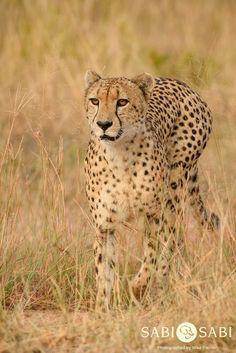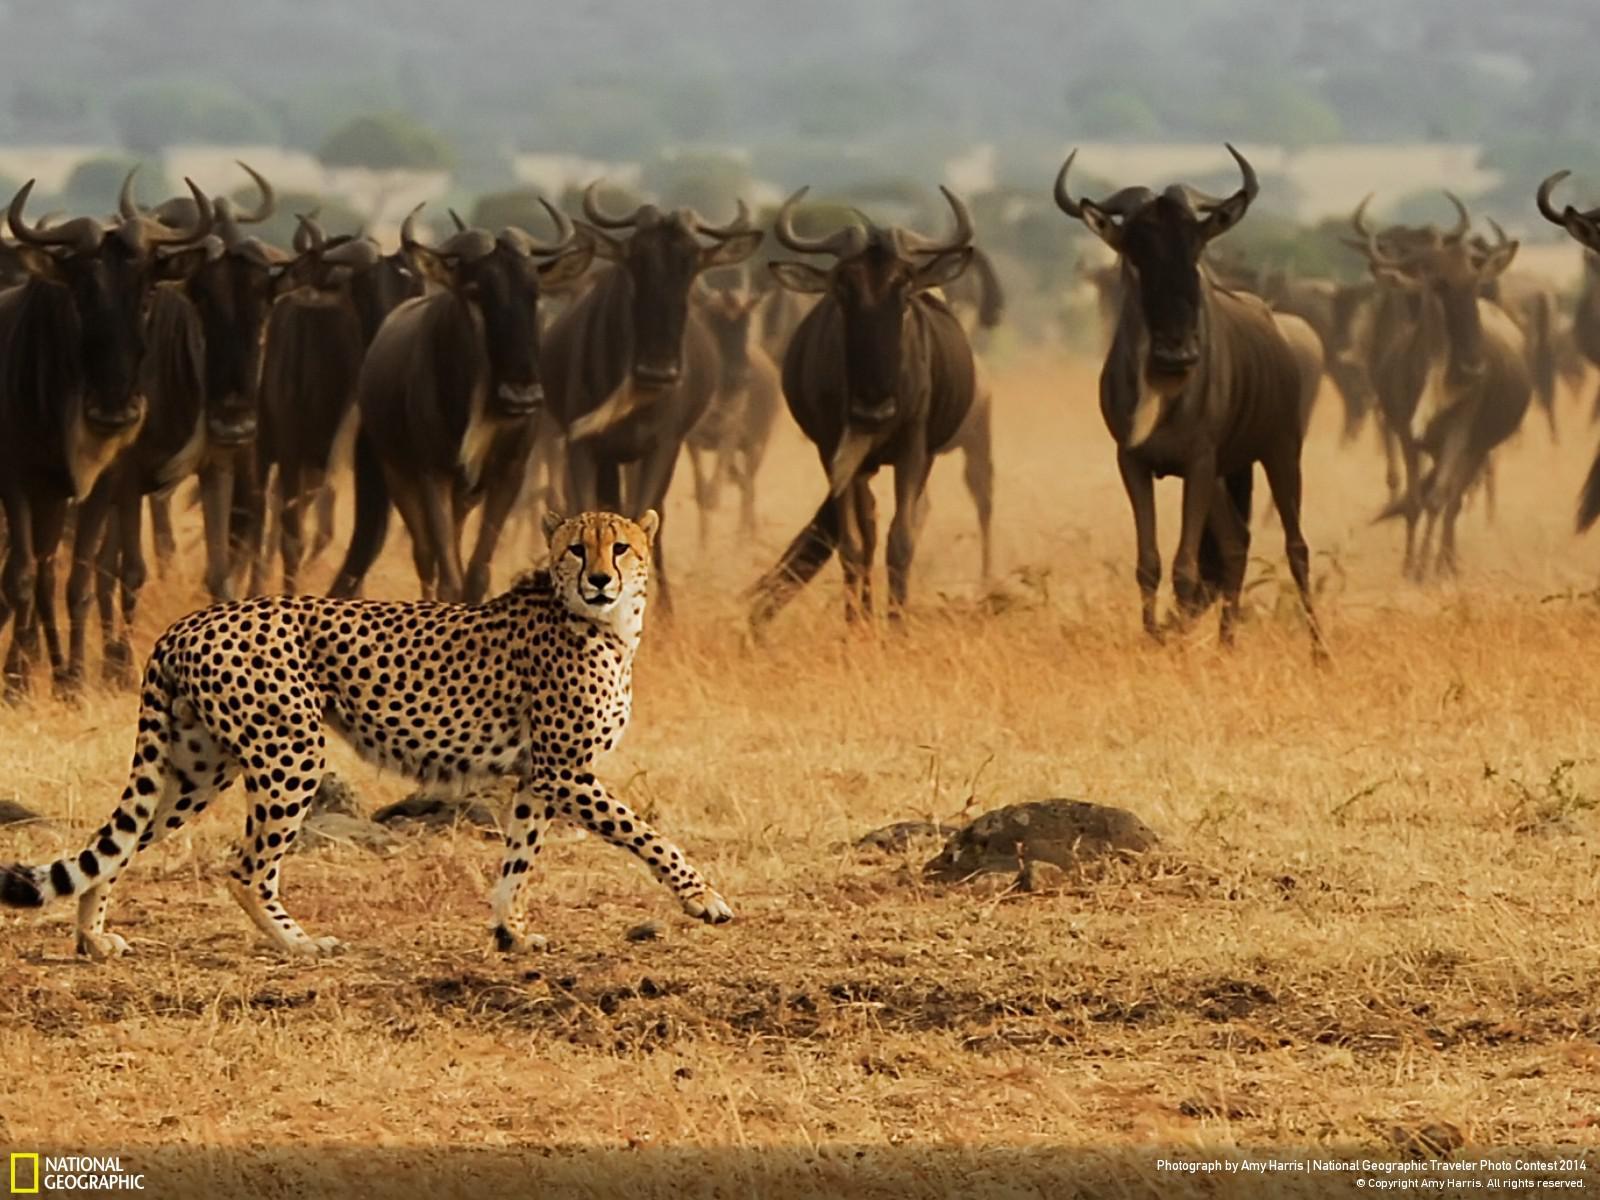The first image is the image on the left, the second image is the image on the right. Analyze the images presented: Is the assertion "there is a single cheetah chasing a deer" valid? Answer yes or no. No. The first image is the image on the left, the second image is the image on the right. For the images displayed, is the sentence "Multiple cheetahs are bounding leftward to attack a gazelle in one image." factually correct? Answer yes or no. No. 